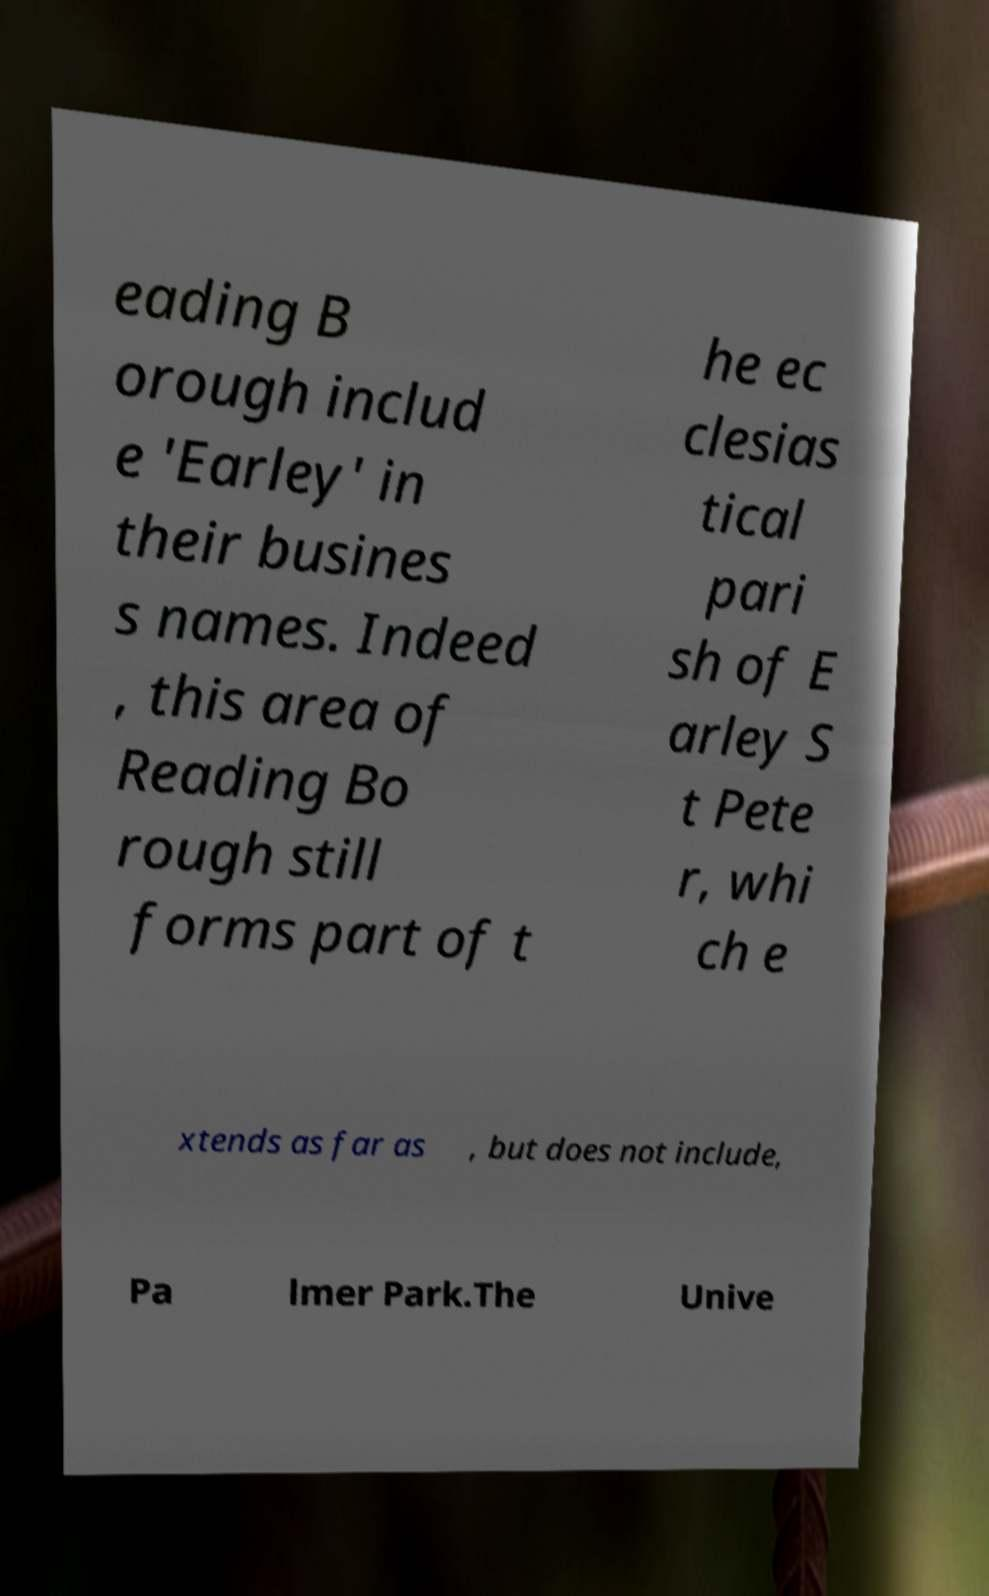There's text embedded in this image that I need extracted. Can you transcribe it verbatim? eading B orough includ e 'Earley' in their busines s names. Indeed , this area of Reading Bo rough still forms part of t he ec clesias tical pari sh of E arley S t Pete r, whi ch e xtends as far as , but does not include, Pa lmer Park.The Unive 